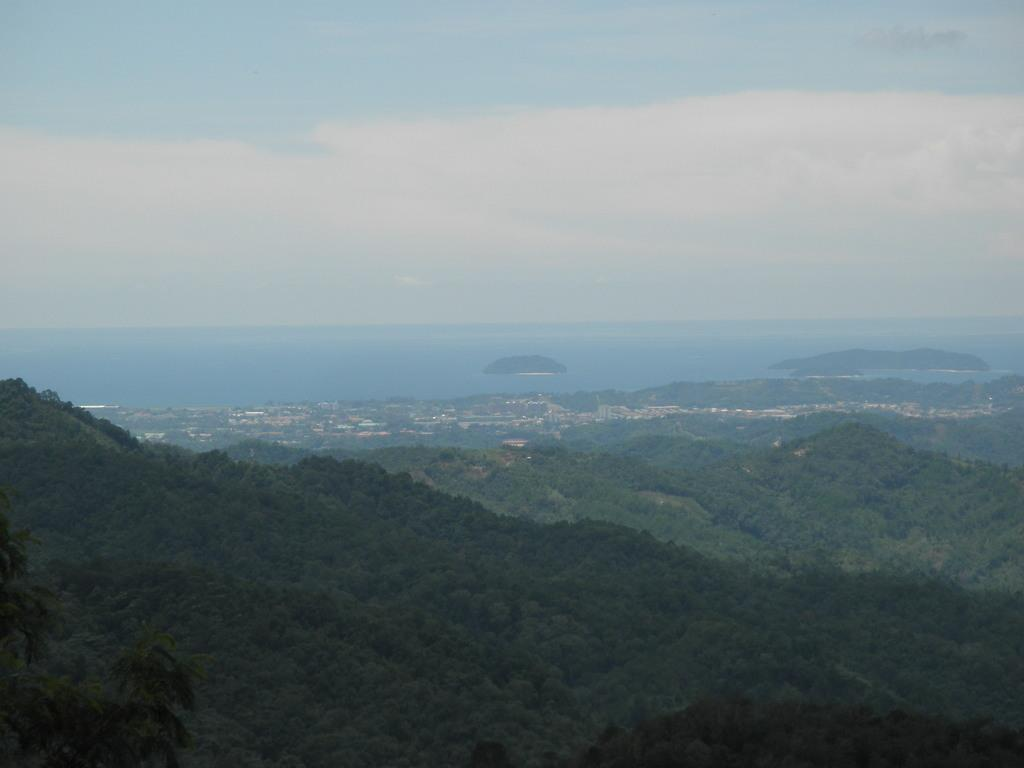What type of landscape is depicted in the image? There are hills with trees in the image. What can be seen in the background of the image? There is water visible in the background of the image. What part of the natural environment is visible in the image? The sky is visible in the image. What is the condition of the sky in the image? Clouds are present in the sky. How many houses can be seen in the image? There are no houses present in the image; it features hills with trees, water in the background, and a sky with clouds. 